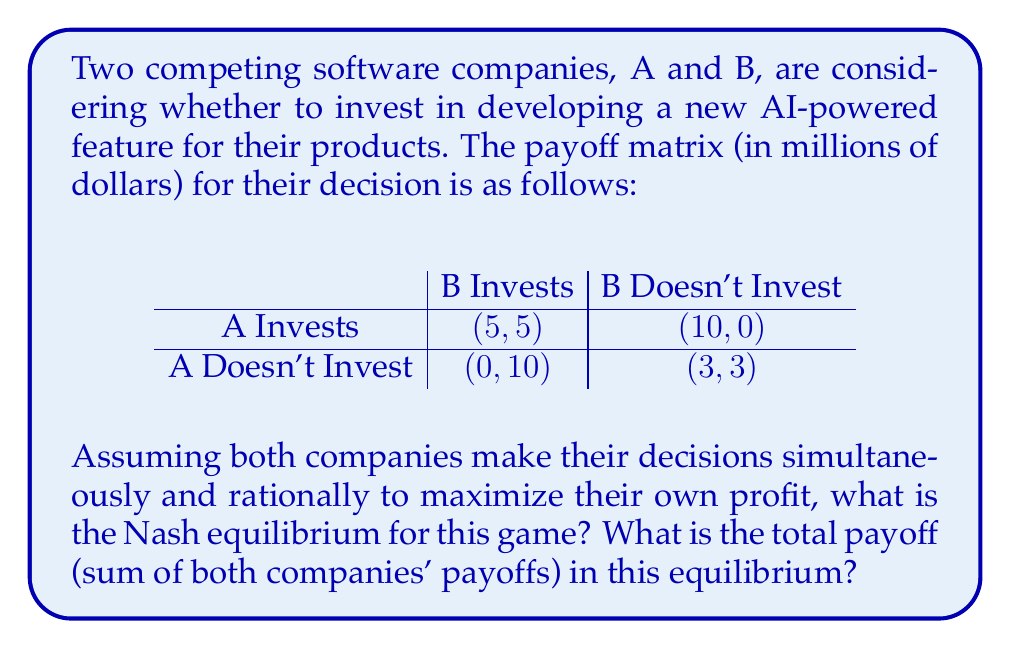Help me with this question. To solve this problem, we need to analyze the game using the concept of Nash equilibrium from game theory. A Nash equilibrium is a set of strategies where no player can unilaterally improve their outcome by changing only their own strategy.

Let's analyze each company's best response to the other's strategies:

1. If B invests:
   - If A invests, A gets 5
   - If A doesn't invest, A gets 0
   So, A's best response is to invest

2. If B doesn't invest:
   - If A invests, A gets 10
   - If A doesn't invest, A gets 3
   So, A's best response is to invest

3. If A invests:
   - If B invests, B gets 5
   - If B doesn't invest, B gets 0
   So, B's best response is to invest

4. If A doesn't invest:
   - If B invests, B gets 10
   - If B doesn't invest, B gets 3
   So, B's best response is to invest

From this analysis, we can see that regardless of what the other company does, both A and B's best strategy is always to invest. This means that (Invest, Invest) is the Nash equilibrium of this game.

In this equilibrium, both companies invest, and each receives a payoff of 5 million dollars. The total payoff is therefore:

$$ \text{Total Payoff} = 5 + 5 = 10 \text{ million dollars} $$
Answer: The Nash equilibrium is (Invest, Invest), and the total payoff in this equilibrium is $10 million. 